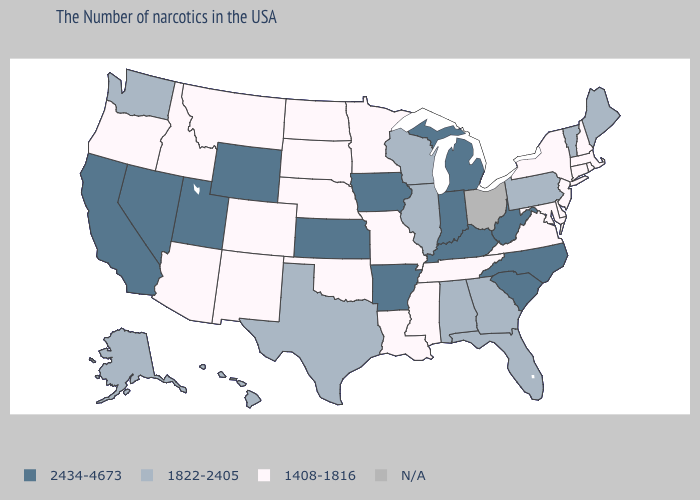What is the lowest value in the MidWest?
Short answer required. 1408-1816. Does Nevada have the highest value in the USA?
Short answer required. Yes. What is the value of Hawaii?
Quick response, please. 1822-2405. How many symbols are there in the legend?
Be succinct. 4. Name the states that have a value in the range 1408-1816?
Give a very brief answer. Massachusetts, Rhode Island, New Hampshire, Connecticut, New York, New Jersey, Delaware, Maryland, Virginia, Tennessee, Mississippi, Louisiana, Missouri, Minnesota, Nebraska, Oklahoma, South Dakota, North Dakota, Colorado, New Mexico, Montana, Arizona, Idaho, Oregon. What is the highest value in states that border Connecticut?
Concise answer only. 1408-1816. What is the highest value in states that border Utah?
Short answer required. 2434-4673. What is the value of New Mexico?
Concise answer only. 1408-1816. Name the states that have a value in the range N/A?
Be succinct. Ohio. Does Nebraska have the highest value in the MidWest?
Keep it brief. No. Name the states that have a value in the range N/A?
Short answer required. Ohio. Does the map have missing data?
Be succinct. Yes. Name the states that have a value in the range N/A?
Answer briefly. Ohio. Does Oklahoma have the highest value in the USA?
Answer briefly. No. What is the lowest value in the West?
Give a very brief answer. 1408-1816. 